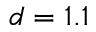<formula> <loc_0><loc_0><loc_500><loc_500>d = 1 . 1</formula> 